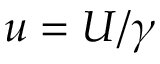Convert formula to latex. <formula><loc_0><loc_0><loc_500><loc_500>u = U / \gamma</formula> 